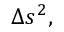<formula> <loc_0><loc_0><loc_500><loc_500>\Delta s ^ { 2 } ,</formula> 